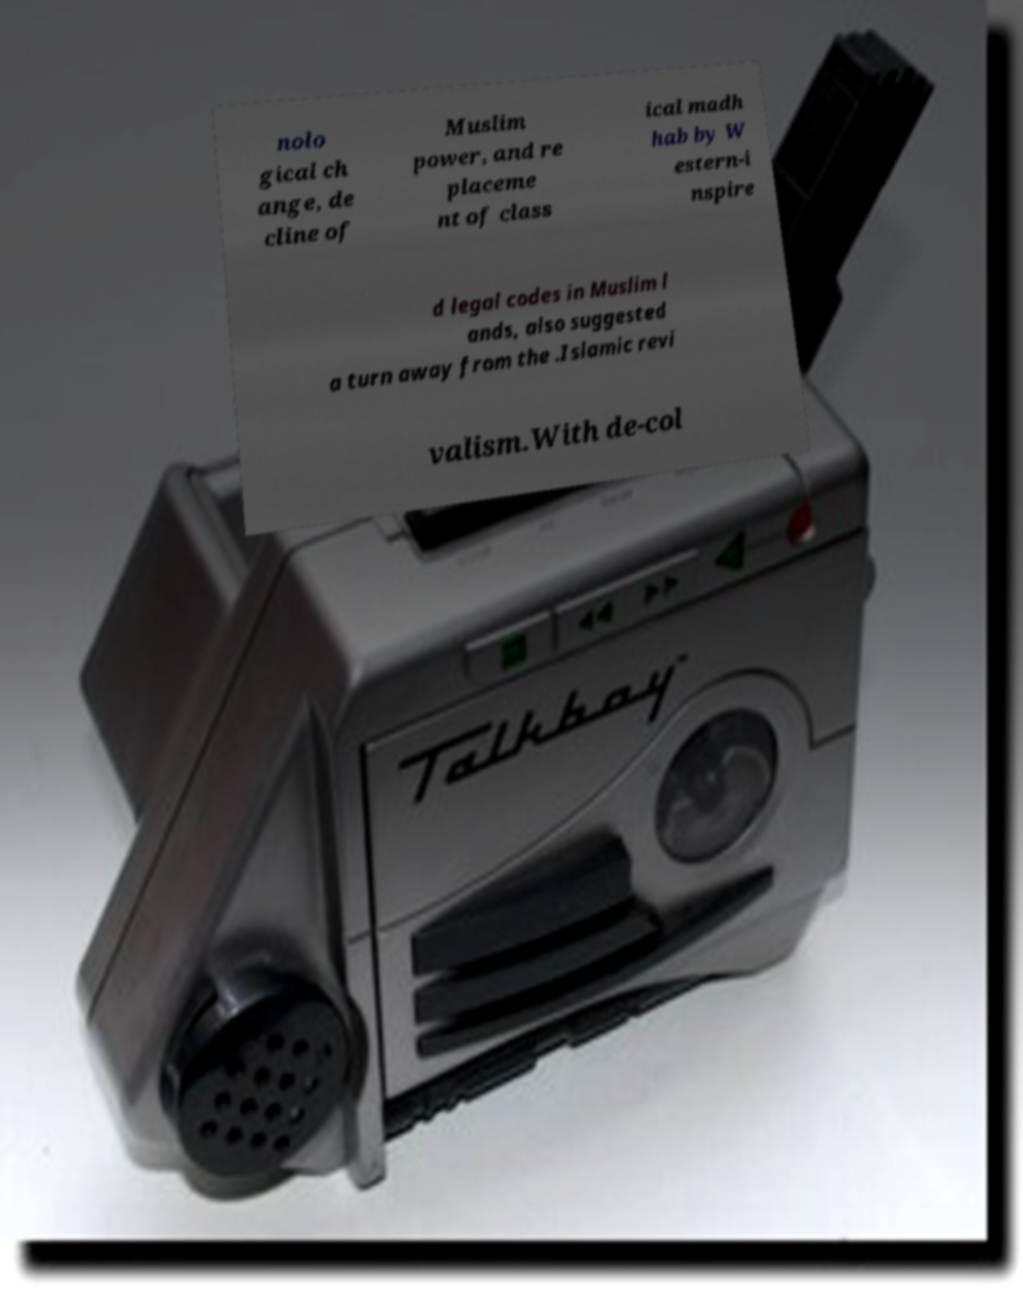I need the written content from this picture converted into text. Can you do that? nolo gical ch ange, de cline of Muslim power, and re placeme nt of class ical madh hab by W estern-i nspire d legal codes in Muslim l ands, also suggested a turn away from the .Islamic revi valism.With de-col 